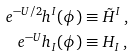Convert formula to latex. <formula><loc_0><loc_0><loc_500><loc_500>e ^ { - U / 2 } h ^ { I } ( \phi ) & \equiv \tilde { H } ^ { I } \, , \\ e ^ { - U } h _ { I } ( \phi ) & \equiv H _ { I } \, ,</formula> 